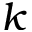<formula> <loc_0><loc_0><loc_500><loc_500>k</formula> 